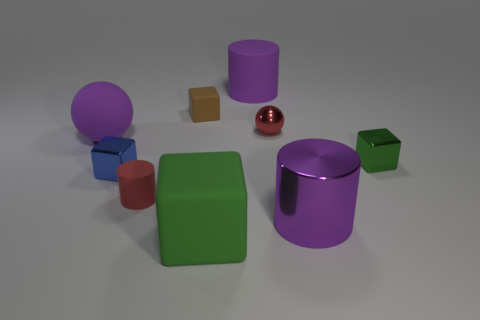What materials do the objects look like they're made from, judging by their surfaces? Judging by their surfaces, the objects seem to be made from different materials. The matte surfaces of the green and brown cubes, the purple cylinder, and the sphere could suggest plastic or painted wood. The shiny red sphere looks metallic or like polished stone. The differing surfaces provide a varied study on how light interacts with various material finishes. 